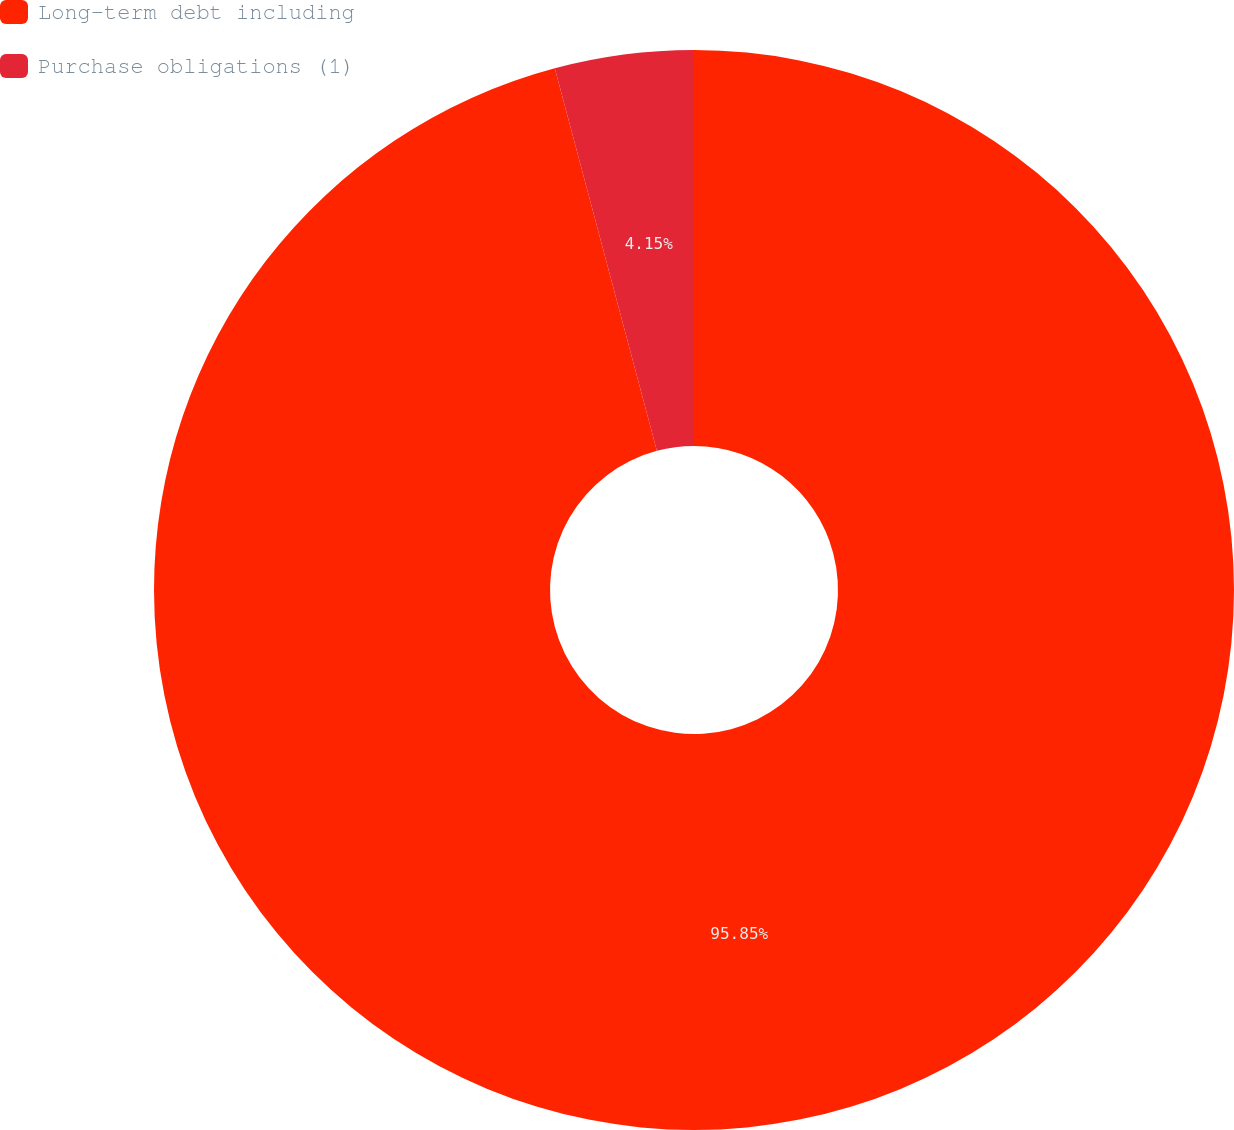Convert chart. <chart><loc_0><loc_0><loc_500><loc_500><pie_chart><fcel>Long-term debt including<fcel>Purchase obligations (1)<nl><fcel>95.85%<fcel>4.15%<nl></chart> 